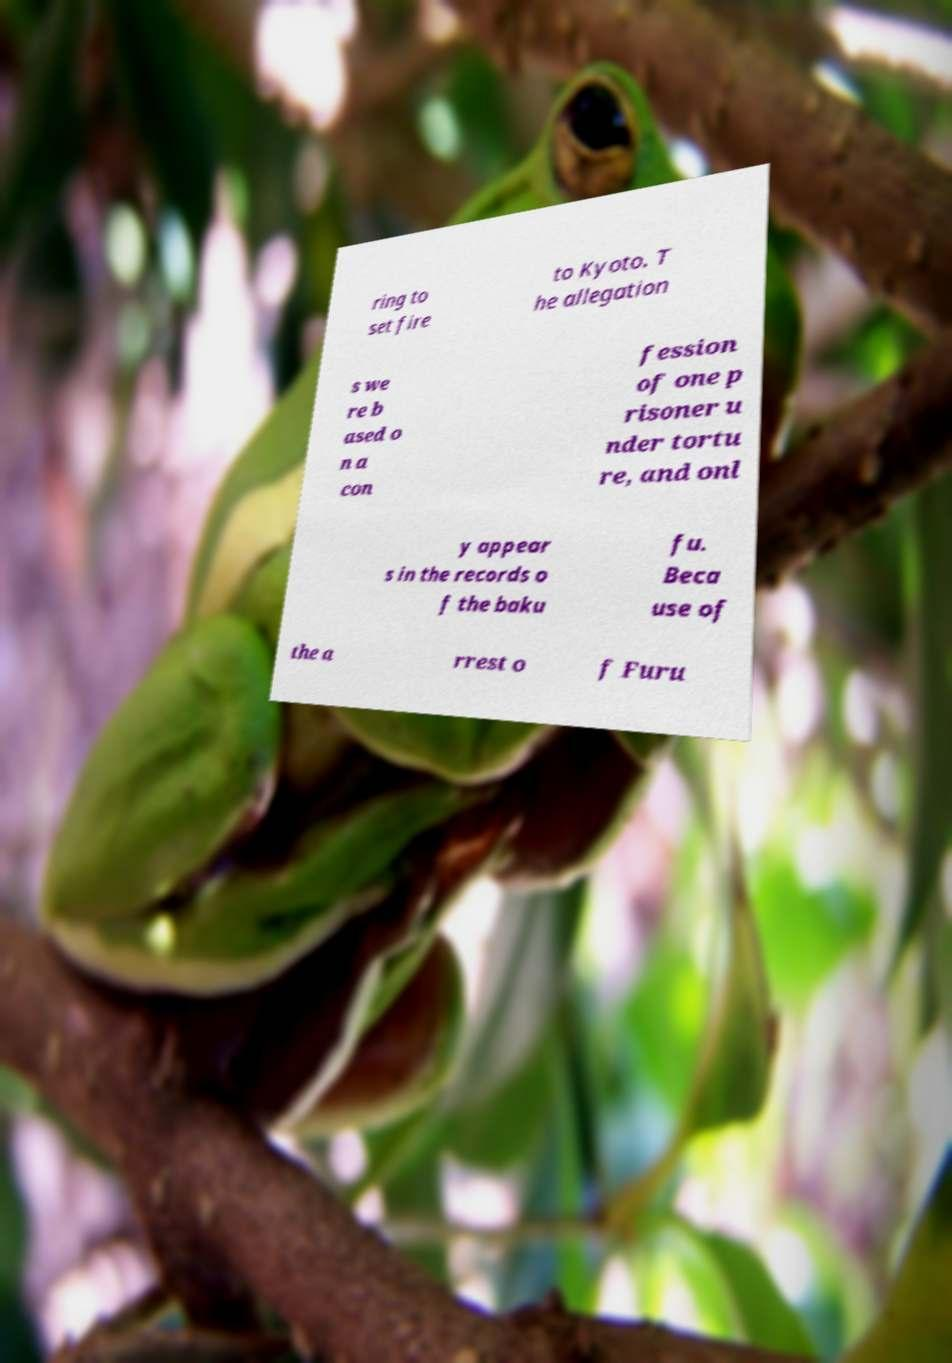Could you assist in decoding the text presented in this image and type it out clearly? ring to set fire to Kyoto. T he allegation s we re b ased o n a con fession of one p risoner u nder tortu re, and onl y appear s in the records o f the baku fu. Beca use of the a rrest o f Furu 